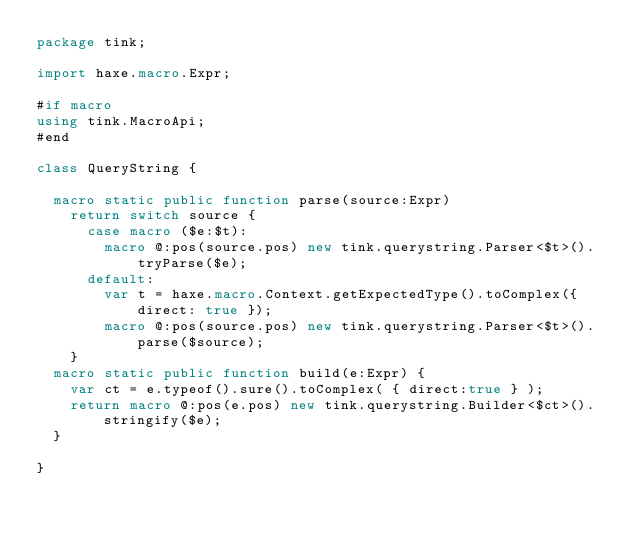Convert code to text. <code><loc_0><loc_0><loc_500><loc_500><_Haxe_>package tink;

import haxe.macro.Expr;

#if macro
using tink.MacroApi;
#end

class QueryString { 
  
  macro static public function parse(source:Expr) 
    return switch source {
      case macro ($e:$t): 
        macro @:pos(source.pos) new tink.querystring.Parser<$t>().tryParse($e);
      default:        
        var t = haxe.macro.Context.getExpectedType().toComplex({ direct: true });
        macro @:pos(source.pos) new tink.querystring.Parser<$t>().parse($source);
    }
  macro static public function build(e:Expr) { 
    var ct = e.typeof().sure().toComplex( { direct:true } );
    return macro @:pos(e.pos) new tink.querystring.Builder<$ct>().stringify($e);
  }
  
}</code> 